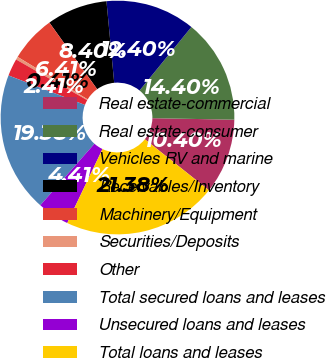<chart> <loc_0><loc_0><loc_500><loc_500><pie_chart><fcel>Real estate-commercial<fcel>Real estate-consumer<fcel>Vehicles RV and marine<fcel>Receivables/Inventory<fcel>Machinery/Equipment<fcel>Securities/Deposits<fcel>Other<fcel>Total secured loans and leases<fcel>Unsecured loans and leases<fcel>Total loans and leases<nl><fcel>10.4%<fcel>14.4%<fcel>12.4%<fcel>8.4%<fcel>6.41%<fcel>0.41%<fcel>2.41%<fcel>19.38%<fcel>4.41%<fcel>21.38%<nl></chart> 